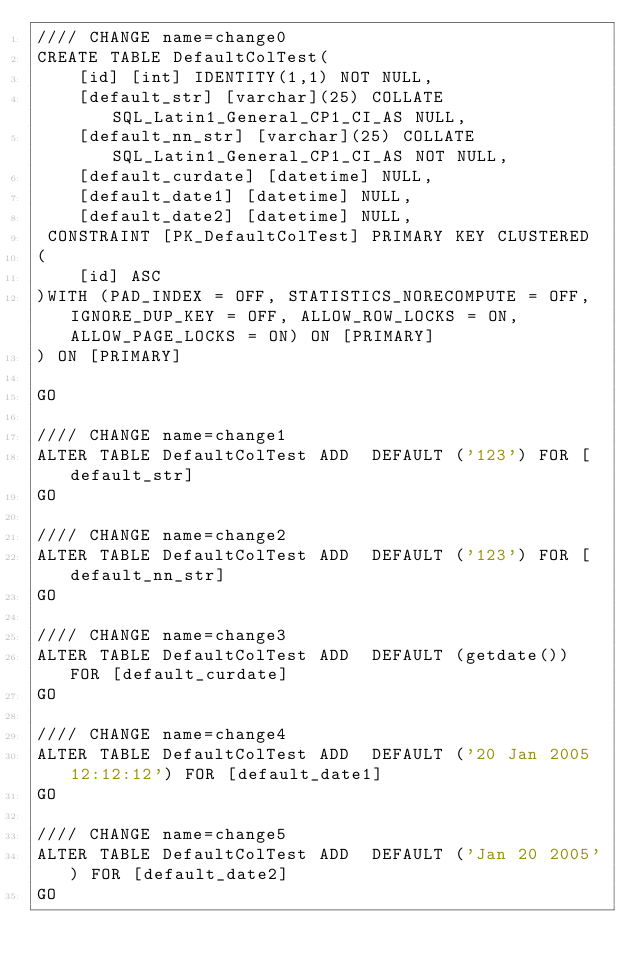<code> <loc_0><loc_0><loc_500><loc_500><_SQL_>//// CHANGE name=change0
CREATE TABLE DefaultColTest(
	[id] [int] IDENTITY(1,1) NOT NULL,
	[default_str] [varchar](25) COLLATE SQL_Latin1_General_CP1_CI_AS NULL,
	[default_nn_str] [varchar](25) COLLATE SQL_Latin1_General_CP1_CI_AS NOT NULL,
	[default_curdate] [datetime] NULL,
	[default_date1] [datetime] NULL,
	[default_date2] [datetime] NULL,
 CONSTRAINT [PK_DefaultColTest] PRIMARY KEY CLUSTERED 
(
	[id] ASC
)WITH (PAD_INDEX = OFF, STATISTICS_NORECOMPUTE = OFF, IGNORE_DUP_KEY = OFF, ALLOW_ROW_LOCKS = ON, ALLOW_PAGE_LOCKS = ON) ON [PRIMARY]
) ON [PRIMARY]

GO

//// CHANGE name=change1
ALTER TABLE DefaultColTest ADD  DEFAULT ('123') FOR [default_str]
GO

//// CHANGE name=change2
ALTER TABLE DefaultColTest ADD  DEFAULT ('123') FOR [default_nn_str]
GO

//// CHANGE name=change3
ALTER TABLE DefaultColTest ADD  DEFAULT (getdate()) FOR [default_curdate]
GO

//// CHANGE name=change4
ALTER TABLE DefaultColTest ADD  DEFAULT ('20 Jan 2005 12:12:12') FOR [default_date1]
GO

//// CHANGE name=change5
ALTER TABLE DefaultColTest ADD  DEFAULT ('Jan 20 2005') FOR [default_date2]
GO
</code> 